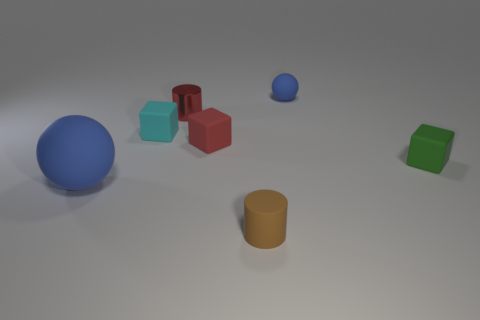Subtract all green rubber cubes. How many cubes are left? 2 Add 1 small red balls. How many objects exist? 8 Subtract all yellow blocks. Subtract all gray cylinders. How many blocks are left? 3 Subtract all spheres. How many objects are left? 5 Subtract 0 cyan cylinders. How many objects are left? 7 Subtract all tiny yellow shiny blocks. Subtract all tiny cyan rubber blocks. How many objects are left? 6 Add 5 small brown cylinders. How many small brown cylinders are left? 6 Add 4 red cylinders. How many red cylinders exist? 5 